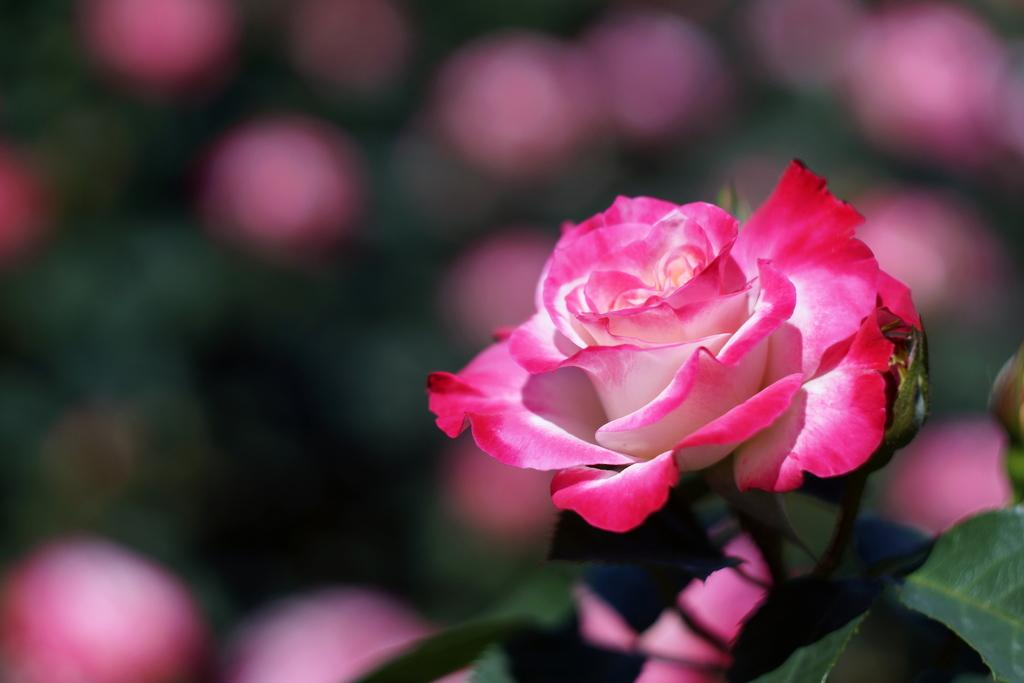What type of plant is on the right side of the image? There is a rose plant on the right side of the image. What is growing on the rose plant? There is a rose on the rose plant. What color is the rose? The rose is pink in color. Who is the writer visiting the playground in the image? There is no writer or playground present in the image; it features a rose plant with a pink rose. 